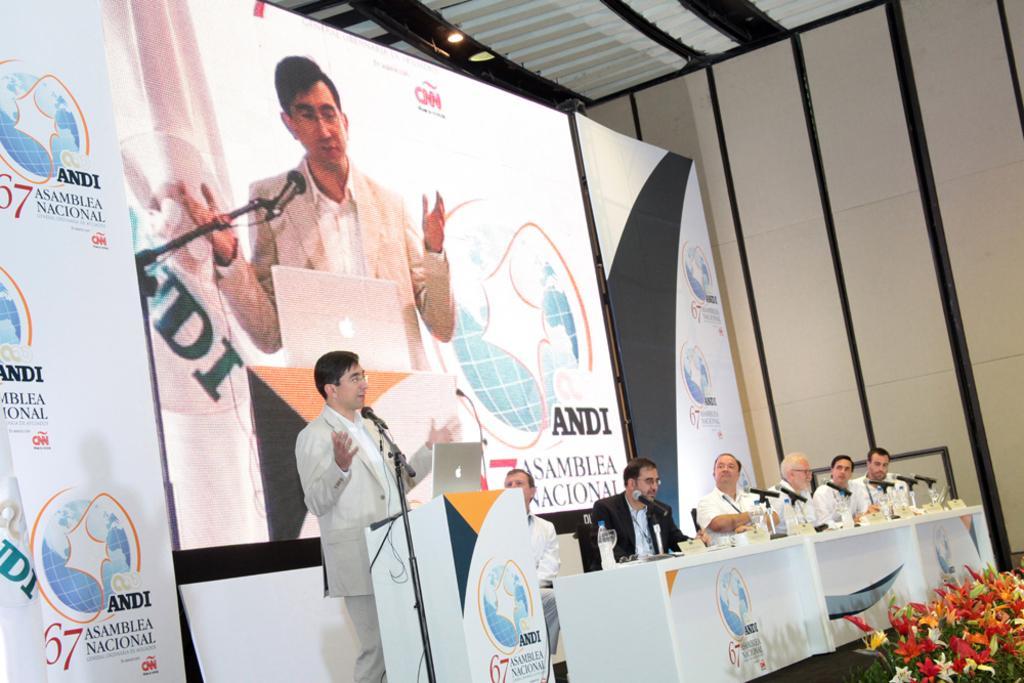How would you summarize this image in a sentence or two? Few people are sitting and this man standing and talking,in front of this man we can see microphone with stand and laptop on the podium. We can see microphones,glasses,bottle and objects on the table. In the background we can see screen and banners,in this screen we can see a man standing. Right side of the image we can see flowers. At the top we can see light. 